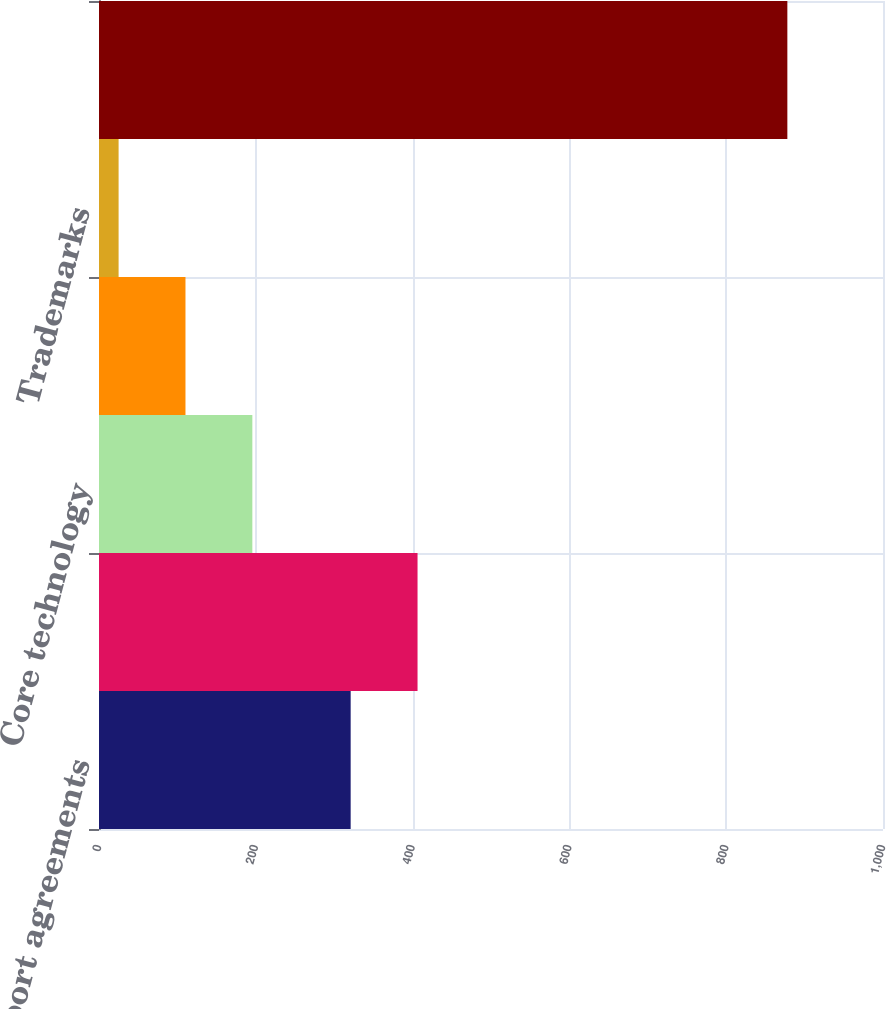Convert chart. <chart><loc_0><loc_0><loc_500><loc_500><bar_chart><fcel>Software support agreements<fcel>Developed technology<fcel>Core technology<fcel>Customer contracts<fcel>Trademarks<fcel>Total amortization of<nl><fcel>321<fcel>406.3<fcel>195.6<fcel>110.3<fcel>25<fcel>878<nl></chart> 